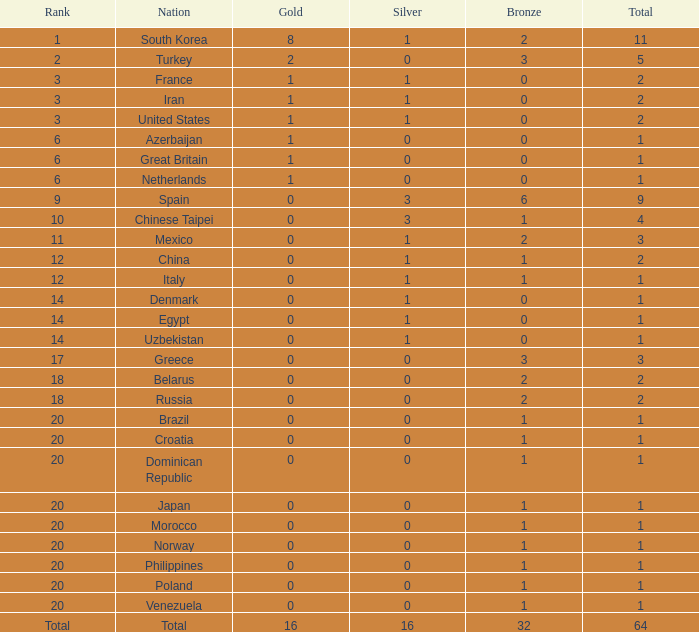How many total silvers does Russia have? 1.0. 